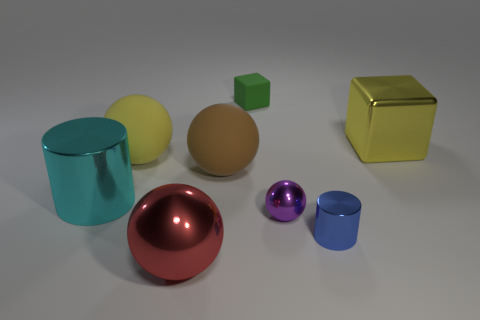Add 1 brown things. How many objects exist? 9 Subtract all blocks. How many objects are left? 6 Add 3 tiny spheres. How many tiny spheres are left? 4 Add 8 tiny gray objects. How many tiny gray objects exist? 8 Subtract 0 gray spheres. How many objects are left? 8 Subtract all big yellow cylinders. Subtract all small purple shiny balls. How many objects are left? 7 